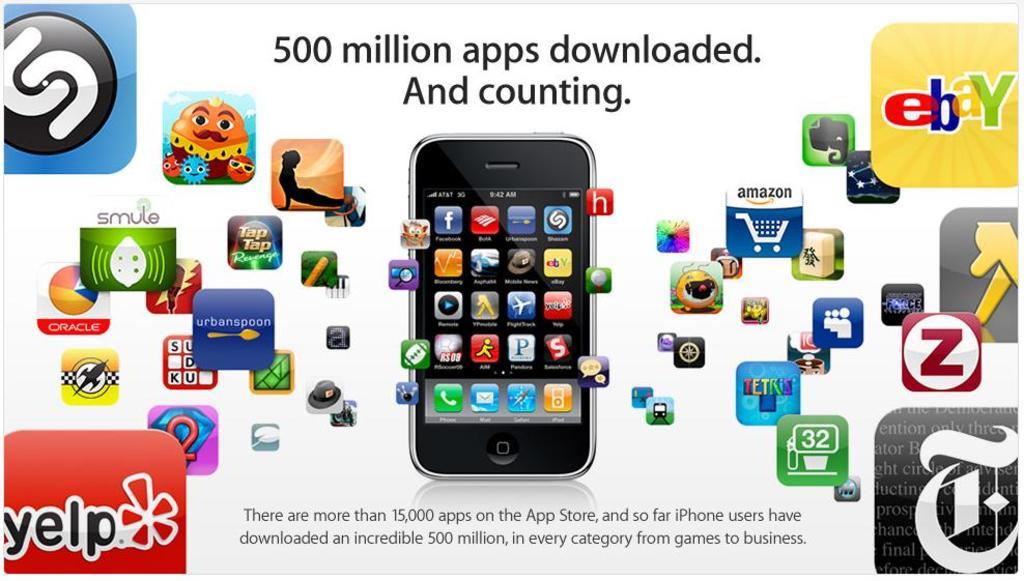How many apps are in the app store for apple products?
Make the answer very short. 500 million. What brand name is in the bottom left corner?
Keep it short and to the point. Yelp. 